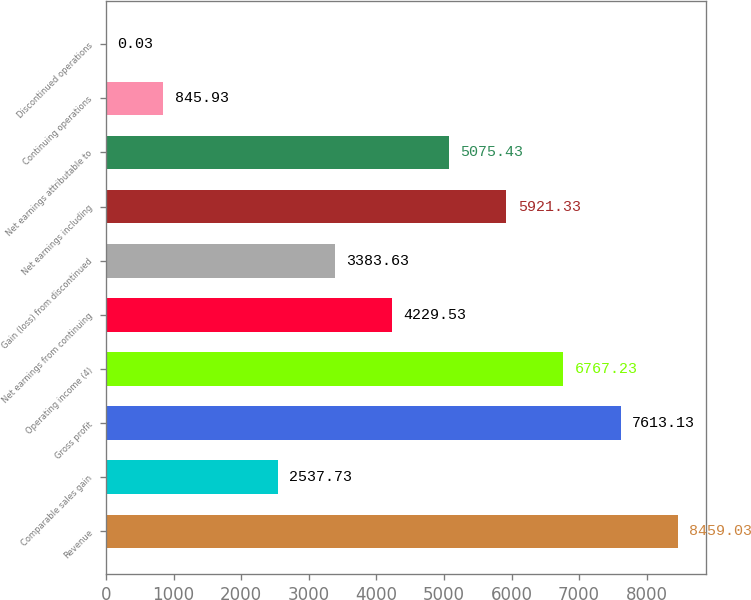Convert chart. <chart><loc_0><loc_0><loc_500><loc_500><bar_chart><fcel>Revenue<fcel>Comparable sales gain<fcel>Gross profit<fcel>Operating income (4)<fcel>Net earnings from continuing<fcel>Gain (loss) from discontinued<fcel>Net earnings including<fcel>Net earnings attributable to<fcel>Continuing operations<fcel>Discontinued operations<nl><fcel>8459.03<fcel>2537.73<fcel>7613.13<fcel>6767.23<fcel>4229.53<fcel>3383.63<fcel>5921.33<fcel>5075.43<fcel>845.93<fcel>0.03<nl></chart> 